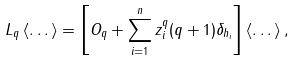<formula> <loc_0><loc_0><loc_500><loc_500>L _ { q } \left \langle \dots \right \rangle = \left [ O _ { q } + \sum ^ { n } _ { i = 1 } z ^ { q } _ { i } ( q + 1 ) \delta _ { h _ { i } } \right ] \left \langle \dots \right \rangle ,</formula> 